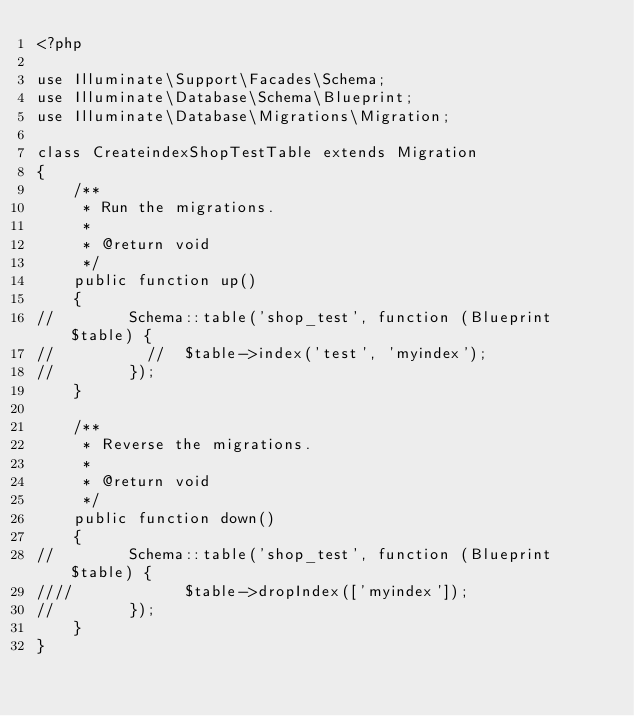Convert code to text. <code><loc_0><loc_0><loc_500><loc_500><_PHP_><?php

use Illuminate\Support\Facades\Schema;
use Illuminate\Database\Schema\Blueprint;
use Illuminate\Database\Migrations\Migration;

class CreateindexShopTestTable extends Migration
{
    /**
     * Run the migrations.
     *
     * @return void
     */
    public function up()
    {
//        Schema::table('shop_test', function (Blueprint $table) {
//          //  $table->index('test', 'myindex');
//        });
    }

    /**
     * Reverse the migrations.
     *
     * @return void
     */
    public function down()
    {
//        Schema::table('shop_test', function (Blueprint $table) {
////            $table->dropIndex(['myindex']);
//        });
    }
}
</code> 